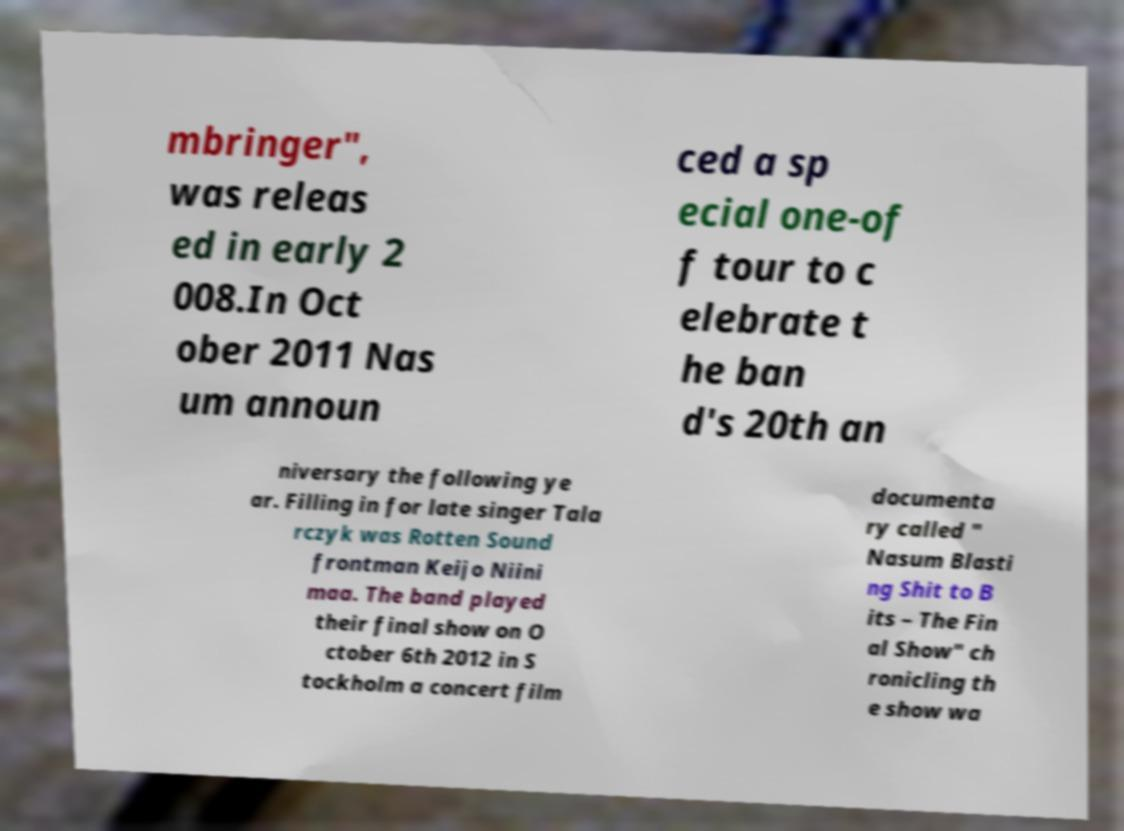Can you read and provide the text displayed in the image?This photo seems to have some interesting text. Can you extract and type it out for me? mbringer", was releas ed in early 2 008.In Oct ober 2011 Nas um announ ced a sp ecial one-of f tour to c elebrate t he ban d's 20th an niversary the following ye ar. Filling in for late singer Tala rczyk was Rotten Sound frontman Keijo Niini maa. The band played their final show on O ctober 6th 2012 in S tockholm a concert film documenta ry called " Nasum Blasti ng Shit to B its – The Fin al Show" ch ronicling th e show wa 